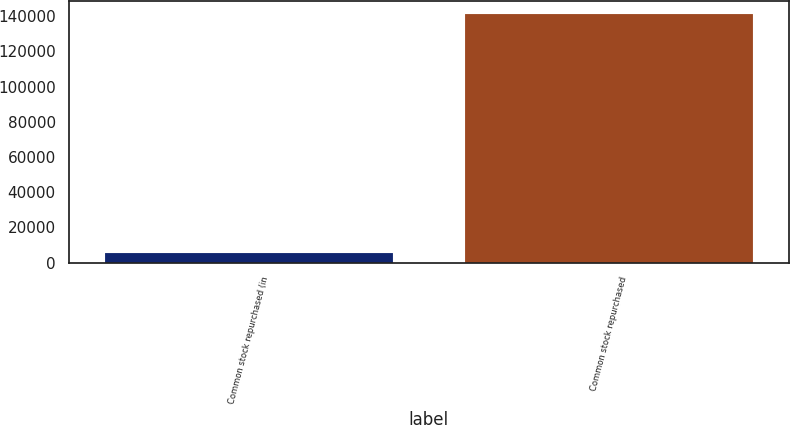Convert chart to OTSL. <chart><loc_0><loc_0><loc_500><loc_500><bar_chart><fcel>Common stock repurchased (in<fcel>Common stock repurchased<nl><fcel>5308<fcel>141552<nl></chart> 